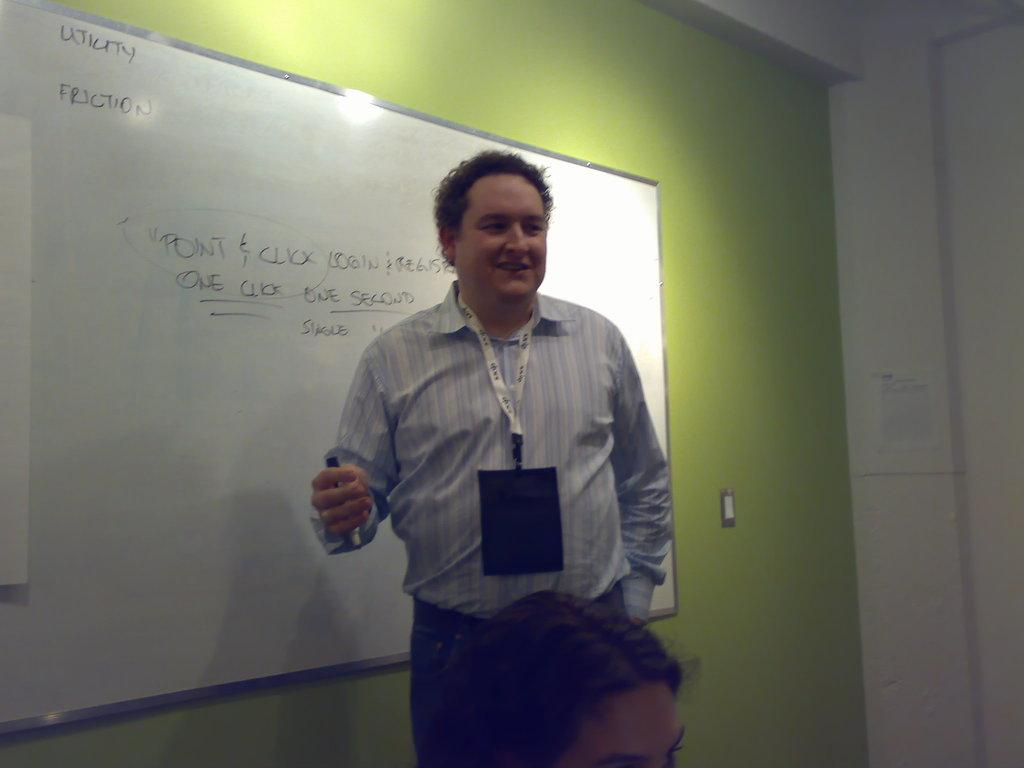Provide a one-sentence caption for the provided image. A man stands in front of a white board with the word, "Utility" written in the corner. 